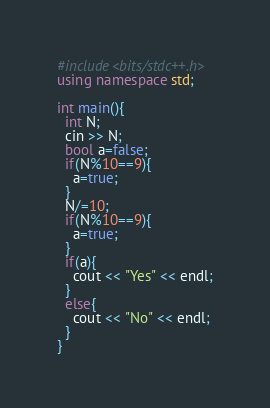<code> <loc_0><loc_0><loc_500><loc_500><_C++_>#include<bits/stdc++.h>
using namespace std;

int main(){
  int N;
  cin >> N;
  bool a=false;
  if(N%10==9){
    a=true;
  }
  N/=10;
  if(N%10==9){
    a=true;
  }
  if(a){
    cout << "Yes" << endl;
  }
  else{
    cout << "No" << endl;
  }
}</code> 